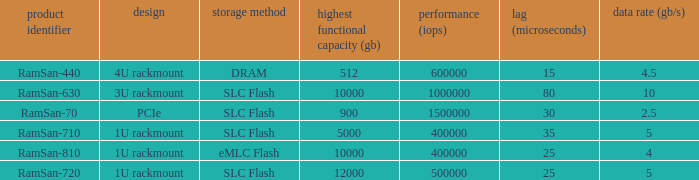What is the range distortion for the ramsan-630? 3U rackmount. 